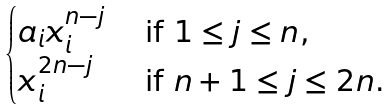<formula> <loc_0><loc_0><loc_500><loc_500>\begin{cases} a _ { i } x _ { i } ^ { n - j } & \text { if $1\leq j\leq n$,} \\ x _ { i } ^ { 2 n - j } & \text { if $n+1\leq j\leq 2n$.} \\ \end{cases}</formula> 